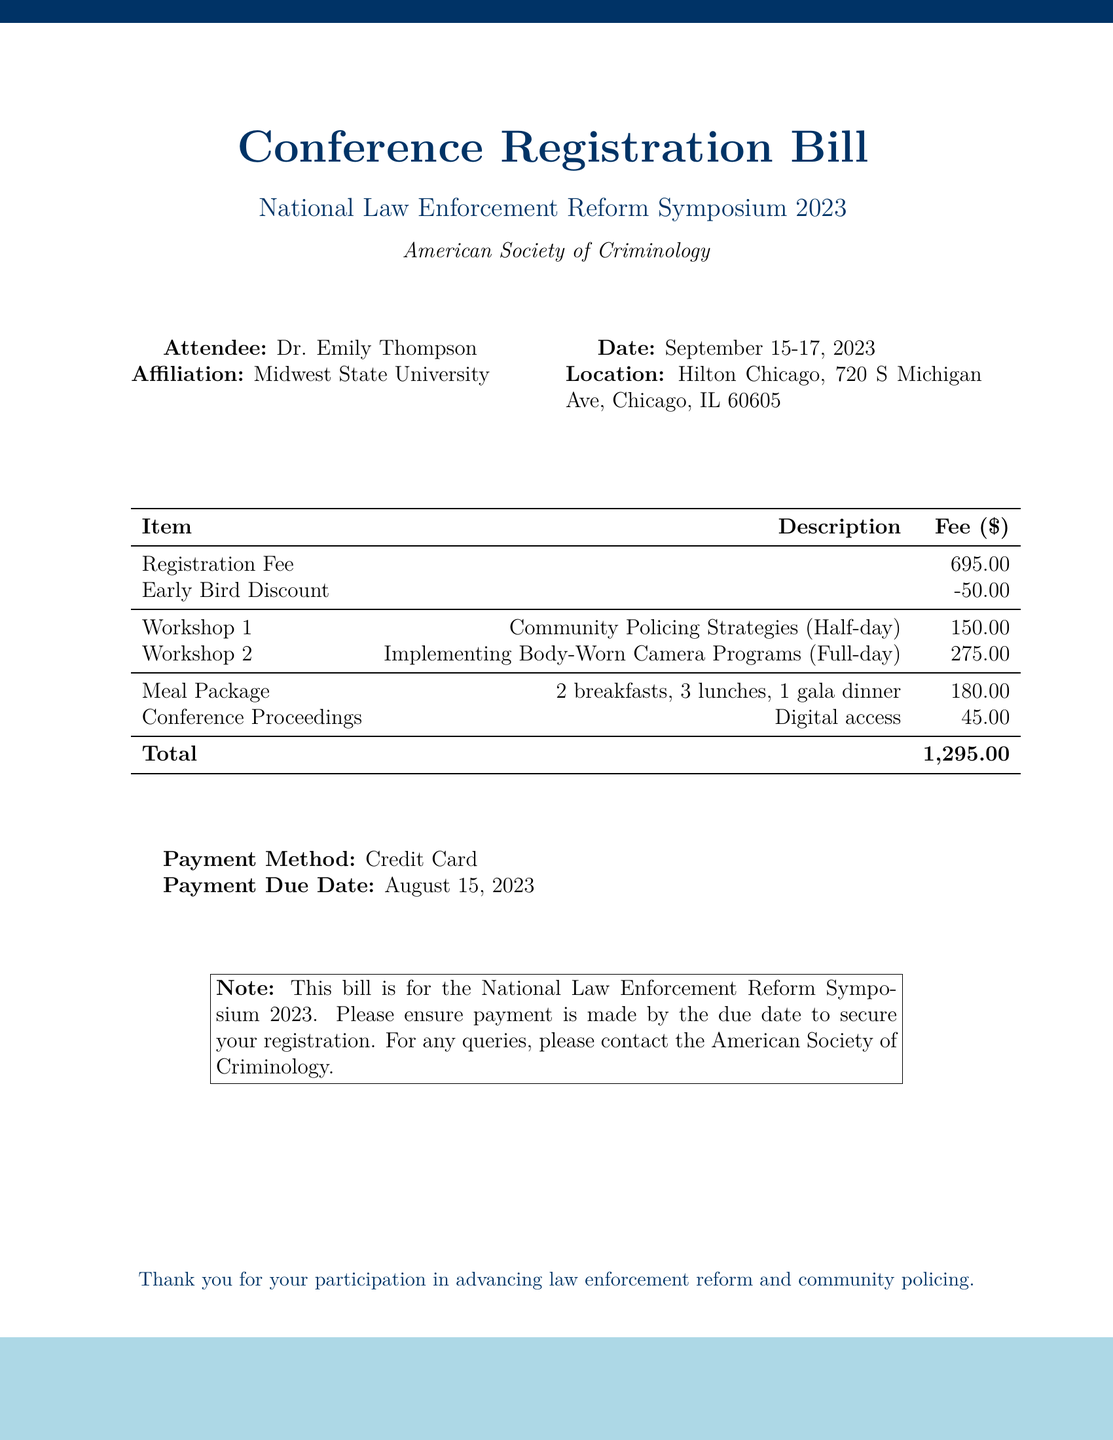What is the total registration fee? The total registration fee is the sum of the registration fee, early bird discount, workshops, meal package, and conference proceedings.
Answer: 1,295.00 Who is the attendee? The document specifies the attendee's name as Dr. Emily Thompson.
Answer: Dr. Emily Thompson What is the date of the conference? The conference date is listed clearly in the document as September 15-17, 2023.
Answer: September 15-17, 2023 What is the location of the event? The location of the conference is provided in the document: Hilton Chicago, 720 S Michigan Ave, Chicago, IL 60605.
Answer: Hilton Chicago, 720 S Michigan Ave, Chicago, IL 60605 How much does the meal package cost? The cost for the meal package is explicitly stated in the document.
Answer: 180.00 What is the payment method? The document indicates that the payment method used for the registration is Credit Card.
Answer: Credit Card What is the early bird discount amount? The document lists the early bird discount that applies to the registration fee.
Answer: -50.00 What workshops are offered in the conference? The two workshops offered are specified in the registration bill.
Answer: Community Policing Strategies, Implementing Body-Worn Camera Programs When is the payment due date? The payment due date for the conference registration fee is mentioned in the bill.
Answer: August 15, 2023 